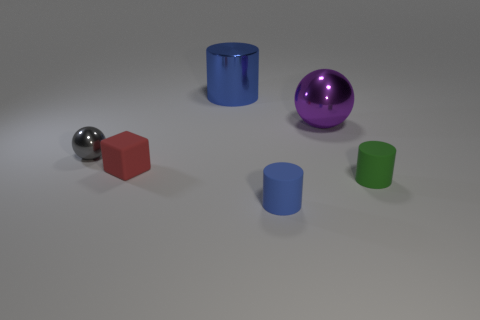How many blue cylinders must be subtracted to get 1 blue cylinders? 1 Subtract all green cylinders. How many cylinders are left? 2 Add 3 blue shiny cubes. How many objects exist? 9 Subtract all purple blocks. How many blue cylinders are left? 2 Subtract all large blue metal objects. Subtract all small matte blocks. How many objects are left? 4 Add 6 red objects. How many red objects are left? 7 Add 6 tiny red shiny spheres. How many tiny red shiny spheres exist? 6 Subtract 0 gray cylinders. How many objects are left? 6 Subtract all cubes. How many objects are left? 5 